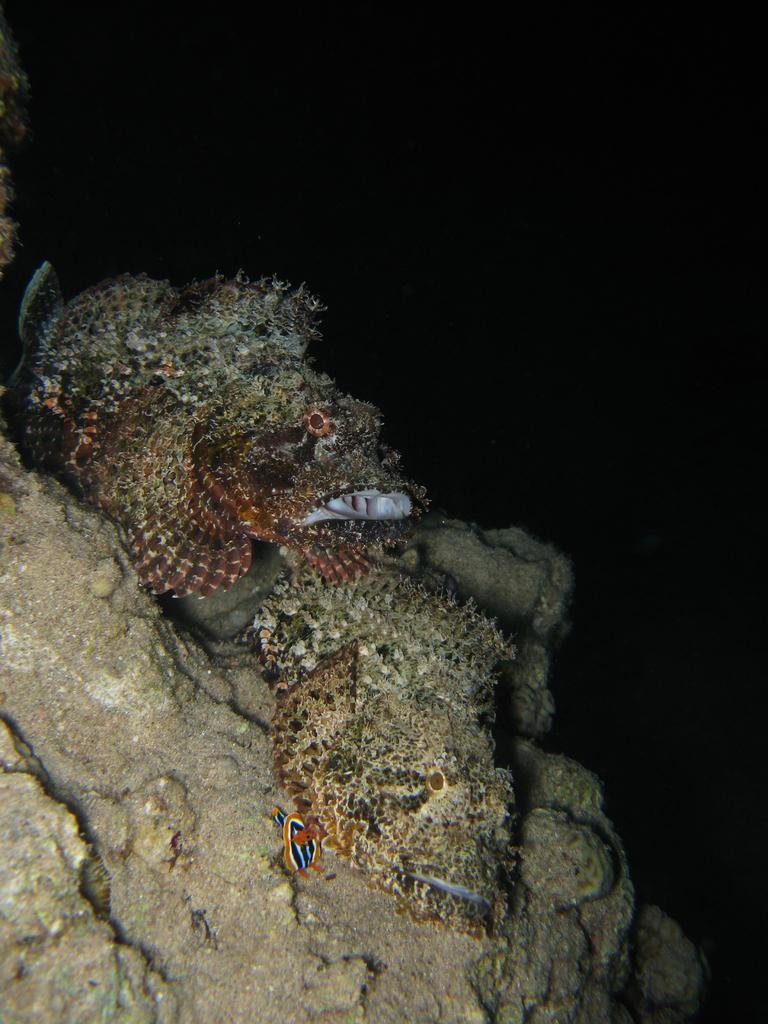What type of animals can be seen on the left side of the image? There are fishes on the left side of the image. What type of vegetation is present in the image? There is moss in the image. What type of terrain is visible in the image? There is sand in the image. Where are the moss and sand located in the image? The moss and sand are on rocks. What is the condition of the rocks in the image? The rocks are underwater. What is the color of the background in the image? The background of the image is dark in color. Can you tell me how many people are in the group that is offering the fishes in the image? There is no group of people offering fishes in the image; it features underwater rocks with moss, sand, and fishes. What type of exercise can be seen being performed by the fishes in the image? There is no exercise being performed by the fishes in the image; they are simply swimming in their natural environment. 